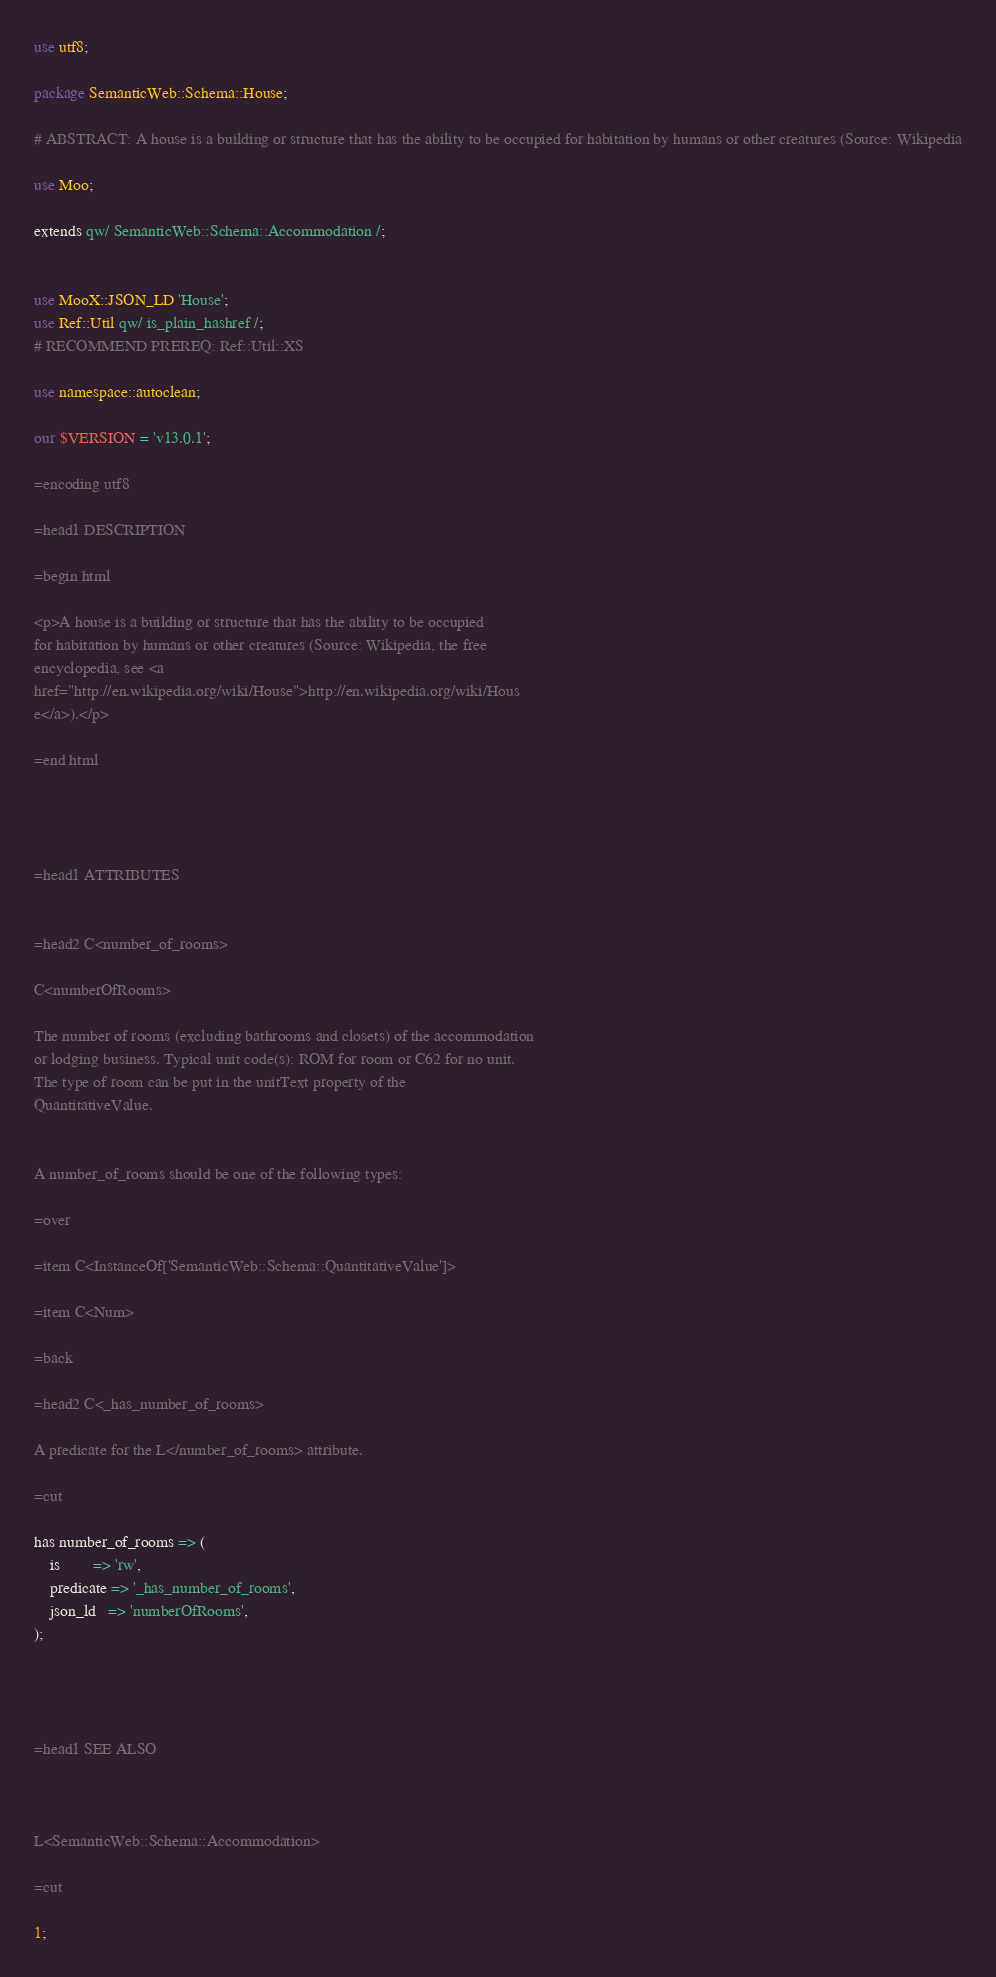<code> <loc_0><loc_0><loc_500><loc_500><_Perl_>use utf8;

package SemanticWeb::Schema::House;

# ABSTRACT: A house is a building or structure that has the ability to be occupied for habitation by humans or other creatures (Source: Wikipedia

use Moo;

extends qw/ SemanticWeb::Schema::Accommodation /;


use MooX::JSON_LD 'House';
use Ref::Util qw/ is_plain_hashref /;
# RECOMMEND PREREQ: Ref::Util::XS

use namespace::autoclean;

our $VERSION = 'v13.0.1';

=encoding utf8

=head1 DESCRIPTION

=begin html

<p>A house is a building or structure that has the ability to be occupied
for habitation by humans or other creatures (Source: Wikipedia, the free
encyclopedia, see <a
href="http://en.wikipedia.org/wiki/House">http://en.wikipedia.org/wiki/Hous
e</a>).</p>

=end html




=head1 ATTRIBUTES


=head2 C<number_of_rooms>

C<numberOfRooms>

The number of rooms (excluding bathrooms and closets) of the accommodation
or lodging business. Typical unit code(s): ROM for room or C62 for no unit.
The type of room can be put in the unitText property of the
QuantitativeValue.


A number_of_rooms should be one of the following types:

=over

=item C<InstanceOf['SemanticWeb::Schema::QuantitativeValue']>

=item C<Num>

=back

=head2 C<_has_number_of_rooms>

A predicate for the L</number_of_rooms> attribute.

=cut

has number_of_rooms => (
    is        => 'rw',
    predicate => '_has_number_of_rooms',
    json_ld   => 'numberOfRooms',
);




=head1 SEE ALSO



L<SemanticWeb::Schema::Accommodation>

=cut

1;
</code> 